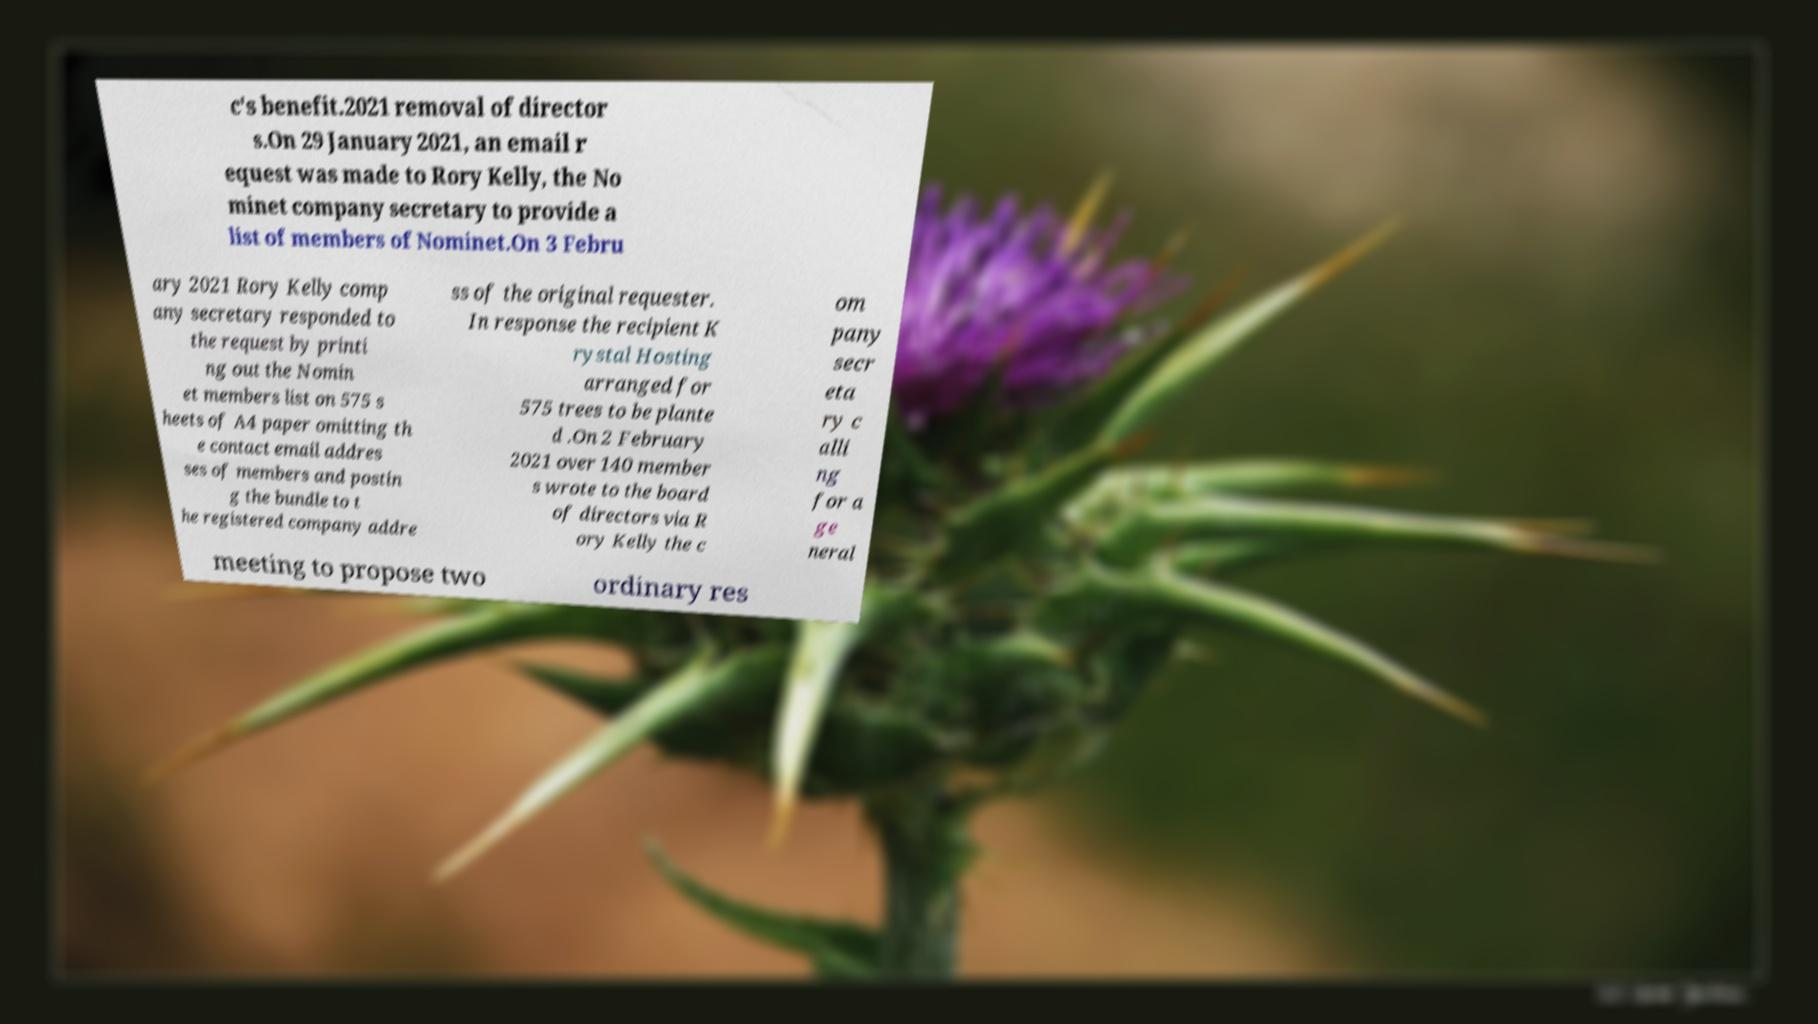There's text embedded in this image that I need extracted. Can you transcribe it verbatim? c's benefit.2021 removal of director s.On 29 January 2021, an email r equest was made to Rory Kelly, the No minet company secretary to provide a list of members of Nominet.On 3 Febru ary 2021 Rory Kelly comp any secretary responded to the request by printi ng out the Nomin et members list on 575 s heets of A4 paper omitting th e contact email addres ses of members and postin g the bundle to t he registered company addre ss of the original requester. In response the recipient K rystal Hosting arranged for 575 trees to be plante d .On 2 February 2021 over 140 member s wrote to the board of directors via R ory Kelly the c om pany secr eta ry c alli ng for a ge neral meeting to propose two ordinary res 